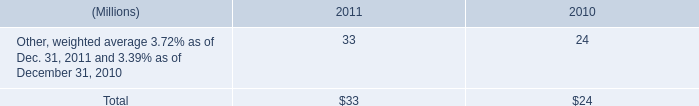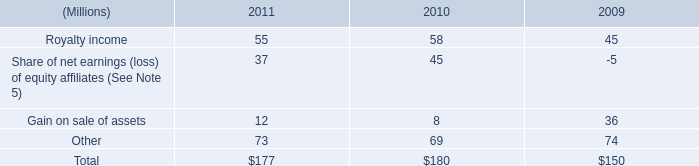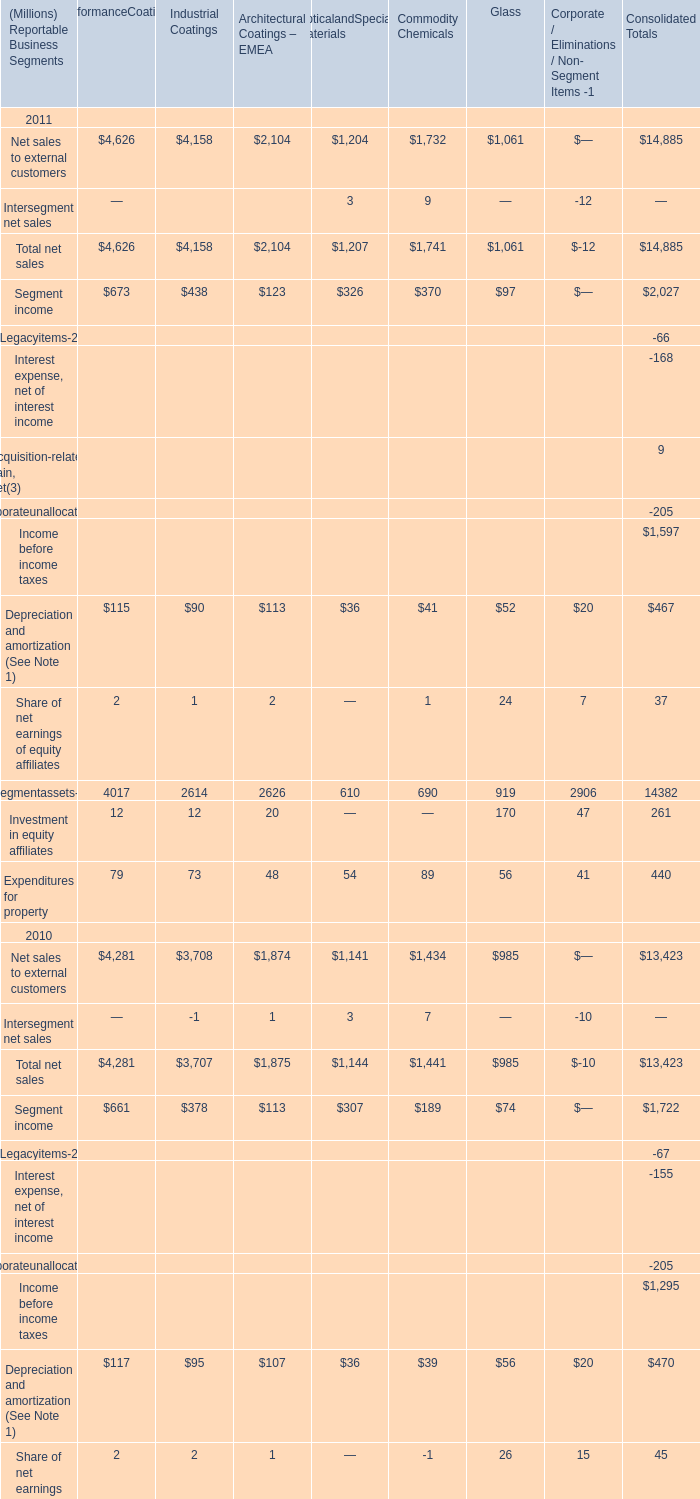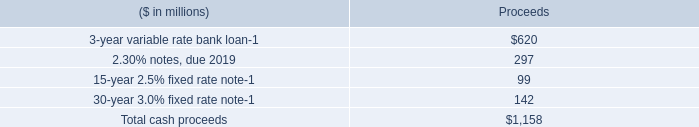In the year with more Total net sales for Commodity Chemicals, what is the growth rate of Total net sales for Glass? 
Computations: ((1061 - 985) / 985)
Answer: 0.07716. 